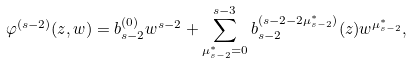<formula> <loc_0><loc_0><loc_500><loc_500>\varphi ^ { ( s - 2 ) } ( z , w ) = b ^ { ( 0 ) } _ { s - 2 } w ^ { s - 2 } + \sum _ { \mu ^ { * } _ { s - 2 } = 0 } ^ { s - 3 } b _ { s - 2 } ^ { ( s - 2 - 2 \mu ^ { * } _ { s - 2 } ) } ( z ) w ^ { \mu ^ { * } _ { s - 2 } } ,</formula> 